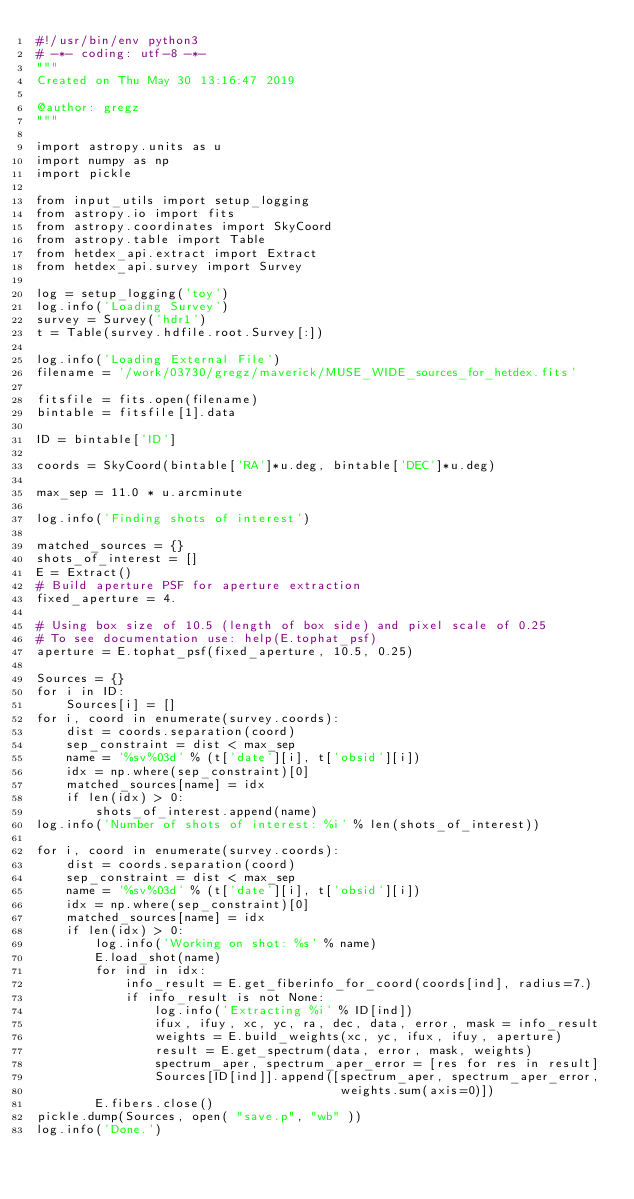Convert code to text. <code><loc_0><loc_0><loc_500><loc_500><_Python_>#!/usr/bin/env python3
# -*- coding: utf-8 -*-
"""
Created on Thu May 30 13:16:47 2019

@author: gregz
"""

import astropy.units as u
import numpy as np
import pickle

from input_utils import setup_logging
from astropy.io import fits
from astropy.coordinates import SkyCoord
from astropy.table import Table
from hetdex_api.extract import Extract 
from hetdex_api.survey import Survey

log = setup_logging('toy')
log.info('Loading Survey')
survey = Survey('hdr1')
t = Table(survey.hdfile.root.Survey[:])

log.info('Loading External File')
filename = '/work/03730/gregz/maverick/MUSE_WIDE_sources_for_hetdex.fits'

fitsfile = fits.open(filename)
bintable = fitsfile[1].data

ID = bintable['ID']

coords = SkyCoord(bintable['RA']*u.deg, bintable['DEC']*u.deg)

max_sep = 11.0 * u.arcminute

log.info('Finding shots of interest')

matched_sources = {}
shots_of_interest = []
E = Extract()
# Build aperture PSF for aperture extraction
fixed_aperture = 4.

# Using box size of 10.5 (length of box side) and pixel scale of 0.25
# To see documentation use: help(E.tophat_psf)
aperture = E.tophat_psf(fixed_aperture, 10.5, 0.25)

Sources = {}
for i in ID:
    Sources[i] = []
for i, coord in enumerate(survey.coords):
    dist = coords.separation(coord)
    sep_constraint = dist < max_sep
    name = '%sv%03d' % (t['date'][i], t['obsid'][i])
    idx = np.where(sep_constraint)[0]
    matched_sources[name] = idx
    if len(idx) > 0:
        shots_of_interest.append(name)
log.info('Number of shots of interest: %i' % len(shots_of_interest))

for i, coord in enumerate(survey.coords):
    dist = coords.separation(coord)
    sep_constraint = dist < max_sep
    name = '%sv%03d' % (t['date'][i], t['obsid'][i])
    idx = np.where(sep_constraint)[0]
    matched_sources[name] = idx
    if len(idx) > 0:
        log.info('Working on shot: %s' % name)
        E.load_shot(name)
        for ind in idx:
            info_result = E.get_fiberinfo_for_coord(coords[ind], radius=7.)
            if info_result is not None:
                log.info('Extracting %i' % ID[ind])
                ifux, ifuy, xc, yc, ra, dec, data, error, mask = info_result
                weights = E.build_weights(xc, yc, ifux, ifuy, aperture)
                result = E.get_spectrum(data, error, mask, weights)
                spectrum_aper, spectrum_aper_error = [res for res in result]
                Sources[ID[ind]].append([spectrum_aper, spectrum_aper_error,
                                         weights.sum(axis=0)])
        E.fibers.close()
pickle.dump(Sources, open( "save.p", "wb" ))
log.info('Done.')</code> 